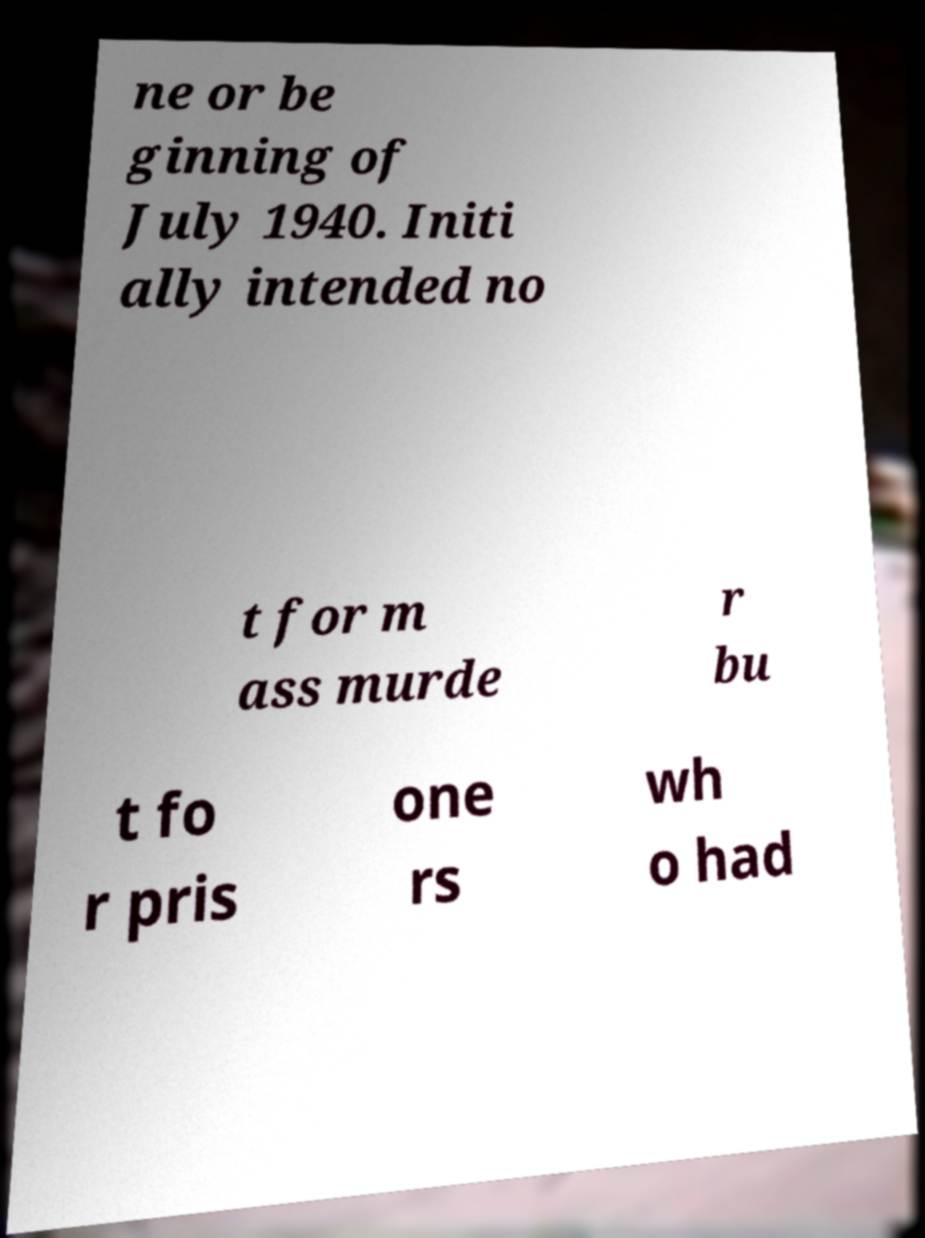I need the written content from this picture converted into text. Can you do that? ne or be ginning of July 1940. Initi ally intended no t for m ass murde r bu t fo r pris one rs wh o had 